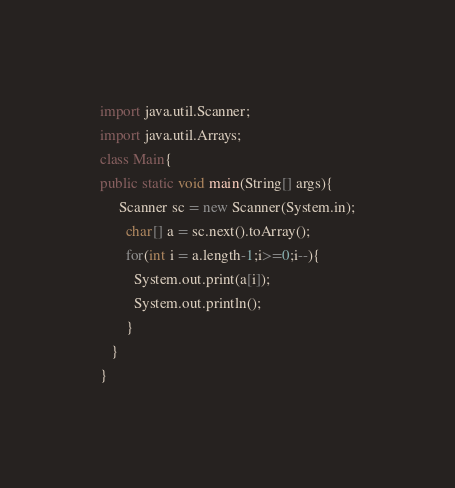Convert code to text. <code><loc_0><loc_0><loc_500><loc_500><_Java_>import java.util.Scanner;
import java.util.Arrays;
class Main{
public static void main(String[] args){
     Scanner sc = new Scanner(System.in);
       char[] a = sc.next().toArray();
       for(int i = a.length-1;i>=0;i--){
         System.out.print(a[i]);
         System.out.println();
       }
   }
}</code> 